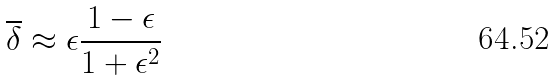Convert formula to latex. <formula><loc_0><loc_0><loc_500><loc_500>\overline { \delta } \approx \epsilon \frac { 1 - \epsilon } { 1 + \epsilon ^ { 2 } }</formula> 